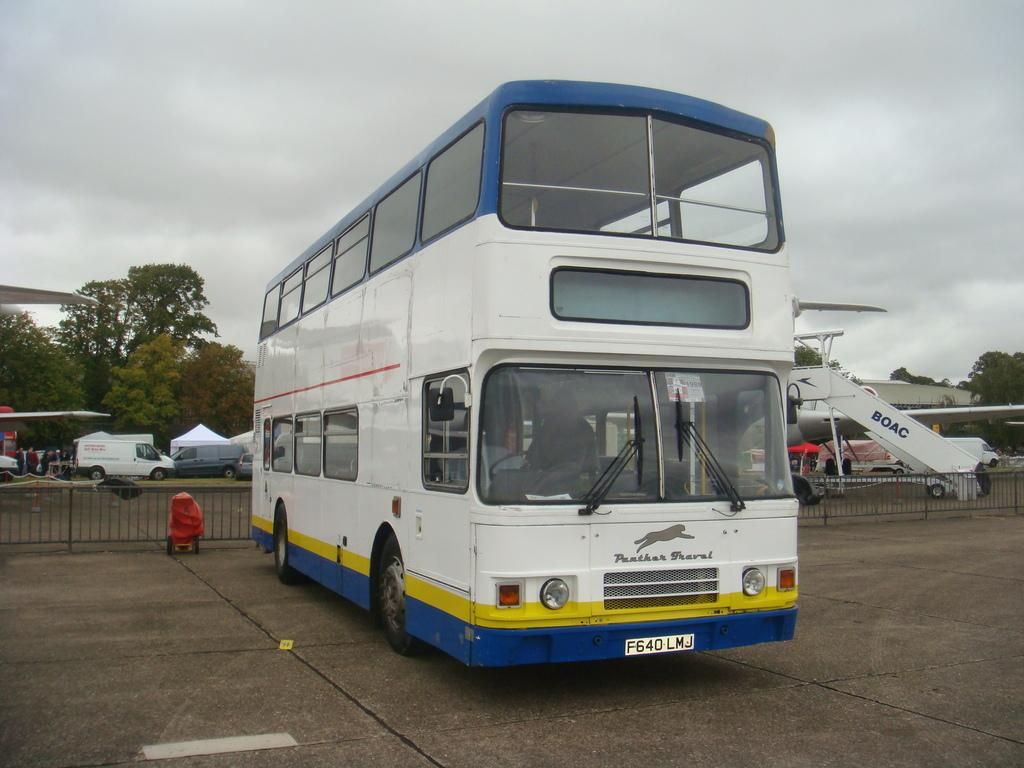What type of transportation is shown in the image? There is a bus and a plane in the image. What else can be seen in the image besides the transportation vehicles? There are vehicles on the side of the image and trees visible in the image. How would you describe the weather in the image? The sky is cloudy in the image. Is there a spy observing the vehicles in the image? There is no indication of a spy in the image. 